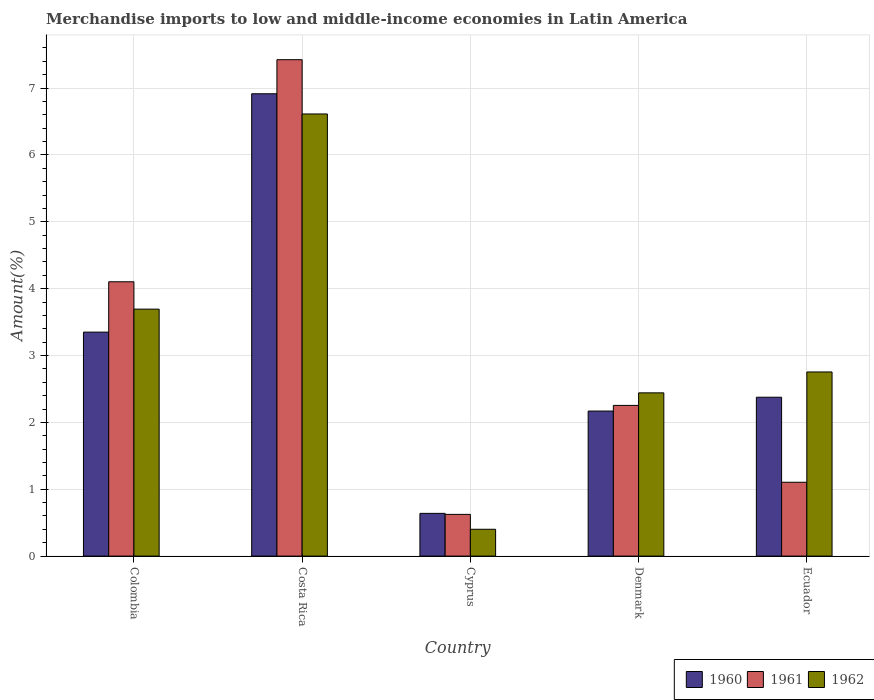Are the number of bars on each tick of the X-axis equal?
Give a very brief answer. Yes. How many bars are there on the 5th tick from the left?
Your answer should be compact. 3. How many bars are there on the 5th tick from the right?
Keep it short and to the point. 3. What is the label of the 3rd group of bars from the left?
Provide a succinct answer. Cyprus. What is the percentage of amount earned from merchandise imports in 1960 in Cyprus?
Provide a short and direct response. 0.64. Across all countries, what is the maximum percentage of amount earned from merchandise imports in 1961?
Give a very brief answer. 7.42. Across all countries, what is the minimum percentage of amount earned from merchandise imports in 1961?
Offer a very short reply. 0.62. In which country was the percentage of amount earned from merchandise imports in 1962 maximum?
Your answer should be very brief. Costa Rica. In which country was the percentage of amount earned from merchandise imports in 1962 minimum?
Make the answer very short. Cyprus. What is the total percentage of amount earned from merchandise imports in 1961 in the graph?
Make the answer very short. 15.51. What is the difference between the percentage of amount earned from merchandise imports in 1960 in Costa Rica and that in Ecuador?
Your answer should be compact. 4.54. What is the difference between the percentage of amount earned from merchandise imports in 1960 in Costa Rica and the percentage of amount earned from merchandise imports in 1961 in Cyprus?
Ensure brevity in your answer.  6.29. What is the average percentage of amount earned from merchandise imports in 1960 per country?
Provide a succinct answer. 3.09. What is the difference between the percentage of amount earned from merchandise imports of/in 1961 and percentage of amount earned from merchandise imports of/in 1960 in Costa Rica?
Provide a succinct answer. 0.51. What is the ratio of the percentage of amount earned from merchandise imports in 1962 in Colombia to that in Denmark?
Provide a short and direct response. 1.51. What is the difference between the highest and the second highest percentage of amount earned from merchandise imports in 1962?
Make the answer very short. -0.94. What is the difference between the highest and the lowest percentage of amount earned from merchandise imports in 1962?
Your answer should be very brief. 6.21. In how many countries, is the percentage of amount earned from merchandise imports in 1962 greater than the average percentage of amount earned from merchandise imports in 1962 taken over all countries?
Your answer should be very brief. 2. What does the 2nd bar from the right in Colombia represents?
Give a very brief answer. 1961. How many bars are there?
Provide a succinct answer. 15. Are all the bars in the graph horizontal?
Offer a very short reply. No. What is the difference between two consecutive major ticks on the Y-axis?
Offer a very short reply. 1. Are the values on the major ticks of Y-axis written in scientific E-notation?
Offer a very short reply. No. Does the graph contain any zero values?
Ensure brevity in your answer.  No. Does the graph contain grids?
Make the answer very short. Yes. How many legend labels are there?
Provide a succinct answer. 3. What is the title of the graph?
Give a very brief answer. Merchandise imports to low and middle-income economies in Latin America. What is the label or title of the X-axis?
Offer a very short reply. Country. What is the label or title of the Y-axis?
Provide a succinct answer. Amount(%). What is the Amount(%) in 1960 in Colombia?
Your response must be concise. 3.35. What is the Amount(%) of 1961 in Colombia?
Your response must be concise. 4.1. What is the Amount(%) of 1962 in Colombia?
Ensure brevity in your answer.  3.69. What is the Amount(%) in 1960 in Costa Rica?
Your answer should be compact. 6.92. What is the Amount(%) of 1961 in Costa Rica?
Keep it short and to the point. 7.42. What is the Amount(%) of 1962 in Costa Rica?
Give a very brief answer. 6.61. What is the Amount(%) of 1960 in Cyprus?
Offer a very short reply. 0.64. What is the Amount(%) of 1961 in Cyprus?
Your answer should be very brief. 0.62. What is the Amount(%) of 1962 in Cyprus?
Your response must be concise. 0.4. What is the Amount(%) in 1960 in Denmark?
Ensure brevity in your answer.  2.17. What is the Amount(%) in 1961 in Denmark?
Your answer should be very brief. 2.25. What is the Amount(%) in 1962 in Denmark?
Give a very brief answer. 2.44. What is the Amount(%) of 1960 in Ecuador?
Your answer should be compact. 2.38. What is the Amount(%) of 1961 in Ecuador?
Your answer should be very brief. 1.1. What is the Amount(%) in 1962 in Ecuador?
Keep it short and to the point. 2.75. Across all countries, what is the maximum Amount(%) of 1960?
Make the answer very short. 6.92. Across all countries, what is the maximum Amount(%) of 1961?
Make the answer very short. 7.42. Across all countries, what is the maximum Amount(%) in 1962?
Provide a short and direct response. 6.61. Across all countries, what is the minimum Amount(%) in 1960?
Keep it short and to the point. 0.64. Across all countries, what is the minimum Amount(%) in 1961?
Make the answer very short. 0.62. Across all countries, what is the minimum Amount(%) in 1962?
Your answer should be very brief. 0.4. What is the total Amount(%) of 1960 in the graph?
Your answer should be compact. 15.45. What is the total Amount(%) in 1961 in the graph?
Provide a succinct answer. 15.51. What is the total Amount(%) in 1962 in the graph?
Provide a succinct answer. 15.9. What is the difference between the Amount(%) of 1960 in Colombia and that in Costa Rica?
Offer a very short reply. -3.57. What is the difference between the Amount(%) of 1961 in Colombia and that in Costa Rica?
Your answer should be compact. -3.32. What is the difference between the Amount(%) in 1962 in Colombia and that in Costa Rica?
Keep it short and to the point. -2.92. What is the difference between the Amount(%) in 1960 in Colombia and that in Cyprus?
Ensure brevity in your answer.  2.71. What is the difference between the Amount(%) of 1961 in Colombia and that in Cyprus?
Give a very brief answer. 3.48. What is the difference between the Amount(%) of 1962 in Colombia and that in Cyprus?
Keep it short and to the point. 3.29. What is the difference between the Amount(%) of 1960 in Colombia and that in Denmark?
Offer a very short reply. 1.18. What is the difference between the Amount(%) in 1961 in Colombia and that in Denmark?
Provide a short and direct response. 1.85. What is the difference between the Amount(%) of 1962 in Colombia and that in Denmark?
Offer a very short reply. 1.25. What is the difference between the Amount(%) in 1960 in Colombia and that in Ecuador?
Ensure brevity in your answer.  0.97. What is the difference between the Amount(%) of 1961 in Colombia and that in Ecuador?
Ensure brevity in your answer.  3. What is the difference between the Amount(%) in 1962 in Colombia and that in Ecuador?
Give a very brief answer. 0.94. What is the difference between the Amount(%) in 1960 in Costa Rica and that in Cyprus?
Your response must be concise. 6.28. What is the difference between the Amount(%) of 1961 in Costa Rica and that in Cyprus?
Your answer should be compact. 6.8. What is the difference between the Amount(%) in 1962 in Costa Rica and that in Cyprus?
Provide a short and direct response. 6.21. What is the difference between the Amount(%) in 1960 in Costa Rica and that in Denmark?
Provide a short and direct response. 4.75. What is the difference between the Amount(%) of 1961 in Costa Rica and that in Denmark?
Offer a very short reply. 5.17. What is the difference between the Amount(%) of 1962 in Costa Rica and that in Denmark?
Provide a succinct answer. 4.17. What is the difference between the Amount(%) of 1960 in Costa Rica and that in Ecuador?
Offer a very short reply. 4.54. What is the difference between the Amount(%) of 1961 in Costa Rica and that in Ecuador?
Offer a very short reply. 6.32. What is the difference between the Amount(%) of 1962 in Costa Rica and that in Ecuador?
Your answer should be compact. 3.86. What is the difference between the Amount(%) in 1960 in Cyprus and that in Denmark?
Your response must be concise. -1.53. What is the difference between the Amount(%) in 1961 in Cyprus and that in Denmark?
Offer a terse response. -1.63. What is the difference between the Amount(%) of 1962 in Cyprus and that in Denmark?
Ensure brevity in your answer.  -2.04. What is the difference between the Amount(%) of 1960 in Cyprus and that in Ecuador?
Your response must be concise. -1.74. What is the difference between the Amount(%) in 1961 in Cyprus and that in Ecuador?
Keep it short and to the point. -0.48. What is the difference between the Amount(%) in 1962 in Cyprus and that in Ecuador?
Offer a very short reply. -2.35. What is the difference between the Amount(%) of 1960 in Denmark and that in Ecuador?
Ensure brevity in your answer.  -0.21. What is the difference between the Amount(%) of 1961 in Denmark and that in Ecuador?
Offer a very short reply. 1.15. What is the difference between the Amount(%) of 1962 in Denmark and that in Ecuador?
Your answer should be compact. -0.31. What is the difference between the Amount(%) in 1960 in Colombia and the Amount(%) in 1961 in Costa Rica?
Give a very brief answer. -4.07. What is the difference between the Amount(%) of 1960 in Colombia and the Amount(%) of 1962 in Costa Rica?
Give a very brief answer. -3.26. What is the difference between the Amount(%) of 1961 in Colombia and the Amount(%) of 1962 in Costa Rica?
Ensure brevity in your answer.  -2.51. What is the difference between the Amount(%) of 1960 in Colombia and the Amount(%) of 1961 in Cyprus?
Keep it short and to the point. 2.73. What is the difference between the Amount(%) in 1960 in Colombia and the Amount(%) in 1962 in Cyprus?
Make the answer very short. 2.95. What is the difference between the Amount(%) in 1961 in Colombia and the Amount(%) in 1962 in Cyprus?
Give a very brief answer. 3.7. What is the difference between the Amount(%) of 1960 in Colombia and the Amount(%) of 1961 in Denmark?
Offer a very short reply. 1.1. What is the difference between the Amount(%) in 1960 in Colombia and the Amount(%) in 1962 in Denmark?
Provide a succinct answer. 0.91. What is the difference between the Amount(%) in 1961 in Colombia and the Amount(%) in 1962 in Denmark?
Offer a terse response. 1.66. What is the difference between the Amount(%) in 1960 in Colombia and the Amount(%) in 1961 in Ecuador?
Give a very brief answer. 2.25. What is the difference between the Amount(%) in 1960 in Colombia and the Amount(%) in 1962 in Ecuador?
Your response must be concise. 0.6. What is the difference between the Amount(%) of 1961 in Colombia and the Amount(%) of 1962 in Ecuador?
Keep it short and to the point. 1.35. What is the difference between the Amount(%) in 1960 in Costa Rica and the Amount(%) in 1961 in Cyprus?
Make the answer very short. 6.29. What is the difference between the Amount(%) in 1960 in Costa Rica and the Amount(%) in 1962 in Cyprus?
Keep it short and to the point. 6.51. What is the difference between the Amount(%) in 1961 in Costa Rica and the Amount(%) in 1962 in Cyprus?
Provide a succinct answer. 7.02. What is the difference between the Amount(%) in 1960 in Costa Rica and the Amount(%) in 1961 in Denmark?
Offer a very short reply. 4.66. What is the difference between the Amount(%) in 1960 in Costa Rica and the Amount(%) in 1962 in Denmark?
Offer a very short reply. 4.47. What is the difference between the Amount(%) of 1961 in Costa Rica and the Amount(%) of 1962 in Denmark?
Your answer should be very brief. 4.98. What is the difference between the Amount(%) in 1960 in Costa Rica and the Amount(%) in 1961 in Ecuador?
Your answer should be compact. 5.81. What is the difference between the Amount(%) in 1960 in Costa Rica and the Amount(%) in 1962 in Ecuador?
Your answer should be compact. 4.16. What is the difference between the Amount(%) of 1961 in Costa Rica and the Amount(%) of 1962 in Ecuador?
Give a very brief answer. 4.67. What is the difference between the Amount(%) of 1960 in Cyprus and the Amount(%) of 1961 in Denmark?
Give a very brief answer. -1.61. What is the difference between the Amount(%) of 1960 in Cyprus and the Amount(%) of 1962 in Denmark?
Give a very brief answer. -1.8. What is the difference between the Amount(%) of 1961 in Cyprus and the Amount(%) of 1962 in Denmark?
Ensure brevity in your answer.  -1.82. What is the difference between the Amount(%) in 1960 in Cyprus and the Amount(%) in 1961 in Ecuador?
Keep it short and to the point. -0.47. What is the difference between the Amount(%) in 1960 in Cyprus and the Amount(%) in 1962 in Ecuador?
Keep it short and to the point. -2.12. What is the difference between the Amount(%) in 1961 in Cyprus and the Amount(%) in 1962 in Ecuador?
Offer a terse response. -2.13. What is the difference between the Amount(%) of 1960 in Denmark and the Amount(%) of 1961 in Ecuador?
Your answer should be compact. 1.07. What is the difference between the Amount(%) of 1960 in Denmark and the Amount(%) of 1962 in Ecuador?
Ensure brevity in your answer.  -0.58. What is the difference between the Amount(%) of 1961 in Denmark and the Amount(%) of 1962 in Ecuador?
Your response must be concise. -0.5. What is the average Amount(%) of 1960 per country?
Keep it short and to the point. 3.09. What is the average Amount(%) in 1961 per country?
Offer a terse response. 3.1. What is the average Amount(%) of 1962 per country?
Give a very brief answer. 3.18. What is the difference between the Amount(%) of 1960 and Amount(%) of 1961 in Colombia?
Your answer should be very brief. -0.75. What is the difference between the Amount(%) in 1960 and Amount(%) in 1962 in Colombia?
Give a very brief answer. -0.34. What is the difference between the Amount(%) of 1961 and Amount(%) of 1962 in Colombia?
Your response must be concise. 0.41. What is the difference between the Amount(%) in 1960 and Amount(%) in 1961 in Costa Rica?
Your response must be concise. -0.51. What is the difference between the Amount(%) in 1960 and Amount(%) in 1962 in Costa Rica?
Your answer should be very brief. 0.3. What is the difference between the Amount(%) in 1961 and Amount(%) in 1962 in Costa Rica?
Keep it short and to the point. 0.81. What is the difference between the Amount(%) of 1960 and Amount(%) of 1961 in Cyprus?
Offer a very short reply. 0.02. What is the difference between the Amount(%) of 1960 and Amount(%) of 1962 in Cyprus?
Provide a succinct answer. 0.24. What is the difference between the Amount(%) of 1961 and Amount(%) of 1962 in Cyprus?
Give a very brief answer. 0.22. What is the difference between the Amount(%) in 1960 and Amount(%) in 1961 in Denmark?
Your answer should be very brief. -0.08. What is the difference between the Amount(%) of 1960 and Amount(%) of 1962 in Denmark?
Provide a succinct answer. -0.27. What is the difference between the Amount(%) in 1961 and Amount(%) in 1962 in Denmark?
Your answer should be very brief. -0.19. What is the difference between the Amount(%) of 1960 and Amount(%) of 1961 in Ecuador?
Give a very brief answer. 1.27. What is the difference between the Amount(%) of 1960 and Amount(%) of 1962 in Ecuador?
Your response must be concise. -0.38. What is the difference between the Amount(%) of 1961 and Amount(%) of 1962 in Ecuador?
Offer a very short reply. -1.65. What is the ratio of the Amount(%) of 1960 in Colombia to that in Costa Rica?
Give a very brief answer. 0.48. What is the ratio of the Amount(%) in 1961 in Colombia to that in Costa Rica?
Keep it short and to the point. 0.55. What is the ratio of the Amount(%) of 1962 in Colombia to that in Costa Rica?
Offer a very short reply. 0.56. What is the ratio of the Amount(%) of 1960 in Colombia to that in Cyprus?
Provide a succinct answer. 5.24. What is the ratio of the Amount(%) of 1961 in Colombia to that in Cyprus?
Your answer should be compact. 6.58. What is the ratio of the Amount(%) of 1962 in Colombia to that in Cyprus?
Offer a terse response. 9.21. What is the ratio of the Amount(%) in 1960 in Colombia to that in Denmark?
Keep it short and to the point. 1.54. What is the ratio of the Amount(%) in 1961 in Colombia to that in Denmark?
Offer a terse response. 1.82. What is the ratio of the Amount(%) of 1962 in Colombia to that in Denmark?
Make the answer very short. 1.51. What is the ratio of the Amount(%) in 1960 in Colombia to that in Ecuador?
Provide a succinct answer. 1.41. What is the ratio of the Amount(%) of 1961 in Colombia to that in Ecuador?
Your response must be concise. 3.72. What is the ratio of the Amount(%) in 1962 in Colombia to that in Ecuador?
Provide a succinct answer. 1.34. What is the ratio of the Amount(%) of 1960 in Costa Rica to that in Cyprus?
Offer a terse response. 10.82. What is the ratio of the Amount(%) in 1961 in Costa Rica to that in Cyprus?
Provide a short and direct response. 11.9. What is the ratio of the Amount(%) in 1962 in Costa Rica to that in Cyprus?
Offer a very short reply. 16.48. What is the ratio of the Amount(%) of 1960 in Costa Rica to that in Denmark?
Offer a very short reply. 3.19. What is the ratio of the Amount(%) in 1961 in Costa Rica to that in Denmark?
Ensure brevity in your answer.  3.29. What is the ratio of the Amount(%) of 1962 in Costa Rica to that in Denmark?
Offer a very short reply. 2.71. What is the ratio of the Amount(%) of 1960 in Costa Rica to that in Ecuador?
Offer a terse response. 2.91. What is the ratio of the Amount(%) in 1961 in Costa Rica to that in Ecuador?
Keep it short and to the point. 6.72. What is the ratio of the Amount(%) in 1962 in Costa Rica to that in Ecuador?
Give a very brief answer. 2.4. What is the ratio of the Amount(%) in 1960 in Cyprus to that in Denmark?
Provide a short and direct response. 0.29. What is the ratio of the Amount(%) of 1961 in Cyprus to that in Denmark?
Your answer should be very brief. 0.28. What is the ratio of the Amount(%) of 1962 in Cyprus to that in Denmark?
Offer a terse response. 0.16. What is the ratio of the Amount(%) in 1960 in Cyprus to that in Ecuador?
Your response must be concise. 0.27. What is the ratio of the Amount(%) in 1961 in Cyprus to that in Ecuador?
Your answer should be compact. 0.56. What is the ratio of the Amount(%) in 1962 in Cyprus to that in Ecuador?
Ensure brevity in your answer.  0.15. What is the ratio of the Amount(%) in 1961 in Denmark to that in Ecuador?
Offer a terse response. 2.04. What is the ratio of the Amount(%) of 1962 in Denmark to that in Ecuador?
Ensure brevity in your answer.  0.89. What is the difference between the highest and the second highest Amount(%) of 1960?
Provide a short and direct response. 3.57. What is the difference between the highest and the second highest Amount(%) of 1961?
Offer a very short reply. 3.32. What is the difference between the highest and the second highest Amount(%) of 1962?
Offer a very short reply. 2.92. What is the difference between the highest and the lowest Amount(%) of 1960?
Make the answer very short. 6.28. What is the difference between the highest and the lowest Amount(%) of 1961?
Provide a succinct answer. 6.8. What is the difference between the highest and the lowest Amount(%) of 1962?
Offer a very short reply. 6.21. 